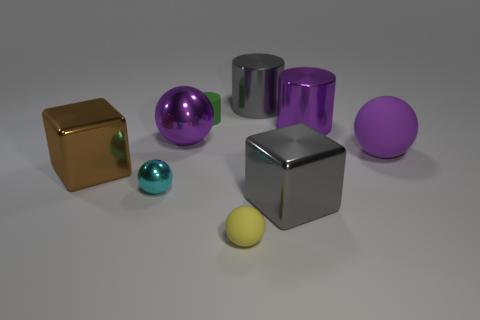Subtract all large gray cylinders. How many cylinders are left? 2 Subtract 2 cylinders. How many cylinders are left? 1 Subtract all gray blocks. How many blocks are left? 1 Subtract all cylinders. How many objects are left? 6 Subtract all red cylinders. How many brown blocks are left? 1 Subtract all big gray cubes. Subtract all cyan metallic spheres. How many objects are left? 7 Add 4 big brown objects. How many big brown objects are left? 5 Add 3 matte objects. How many matte objects exist? 6 Subtract 0 red spheres. How many objects are left? 9 Subtract all purple cubes. Subtract all yellow balls. How many cubes are left? 2 